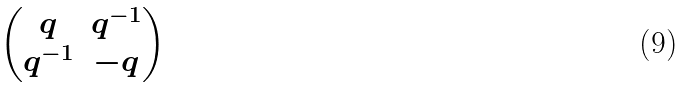Convert formula to latex. <formula><loc_0><loc_0><loc_500><loc_500>\begin{pmatrix} q & q ^ { - 1 } \\ q ^ { - 1 } & - q \end{pmatrix}</formula> 